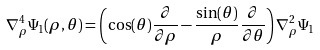Convert formula to latex. <formula><loc_0><loc_0><loc_500><loc_500>\nabla _ { \rho } ^ { 4 } \Psi _ { 1 } ( \rho , \theta ) = \left ( \cos ( \theta ) \frac { \partial } { \partial \rho } - \frac { \sin ( \theta ) } { \rho } \frac { \partial } { \partial \theta } \right ) \nabla _ { \rho } ^ { 2 } \Psi _ { 1 }</formula> 